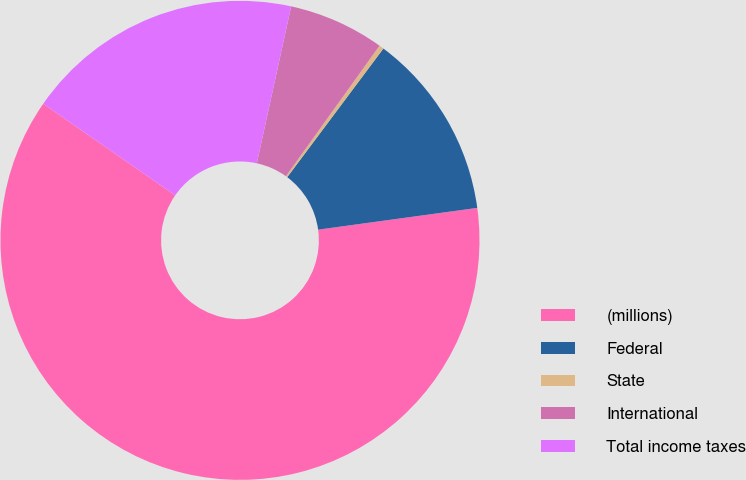<chart> <loc_0><loc_0><loc_500><loc_500><pie_chart><fcel>(millions)<fcel>Federal<fcel>State<fcel>International<fcel>Total income taxes<nl><fcel>61.83%<fcel>12.62%<fcel>0.32%<fcel>6.47%<fcel>18.77%<nl></chart> 